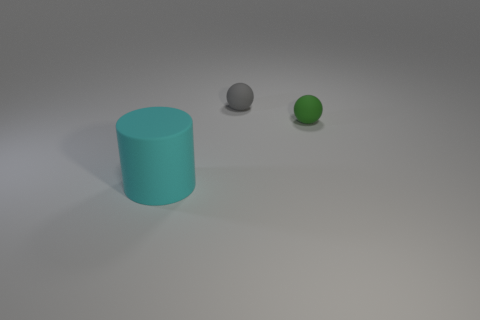What number of large cyan shiny objects have the same shape as the green matte thing?
Your answer should be very brief. 0. What is the size of the cylinder that is made of the same material as the tiny gray sphere?
Give a very brief answer. Large. There is a ball that is behind the ball in front of the gray thing; are there any matte things to the left of it?
Provide a short and direct response. Yes. There is a thing that is to the right of the gray object; is it the same size as the cylinder?
Provide a short and direct response. No. What number of gray objects are the same size as the green thing?
Ensure brevity in your answer.  1. The tiny gray rubber thing is what shape?
Your answer should be very brief. Sphere. Are there more tiny spheres that are behind the rubber cylinder than yellow cylinders?
Your answer should be compact. Yes. Is the shape of the green rubber thing the same as the rubber thing that is to the left of the gray sphere?
Ensure brevity in your answer.  No. Are there any small brown metallic cylinders?
Offer a very short reply. No. What number of big objects are purple metal balls or gray matte objects?
Provide a short and direct response. 0. 